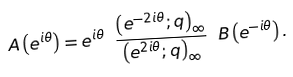<formula> <loc_0><loc_0><loc_500><loc_500>A \left ( e ^ { i \theta } \right ) = e ^ { i \theta } \ \frac { \left ( e ^ { - 2 i \theta } ; q \right ) _ { \infty } } { \left ( e ^ { 2 i \theta } ; q \right ) _ { \infty } } \ B \left ( e ^ { - i \theta } \right ) .</formula> 